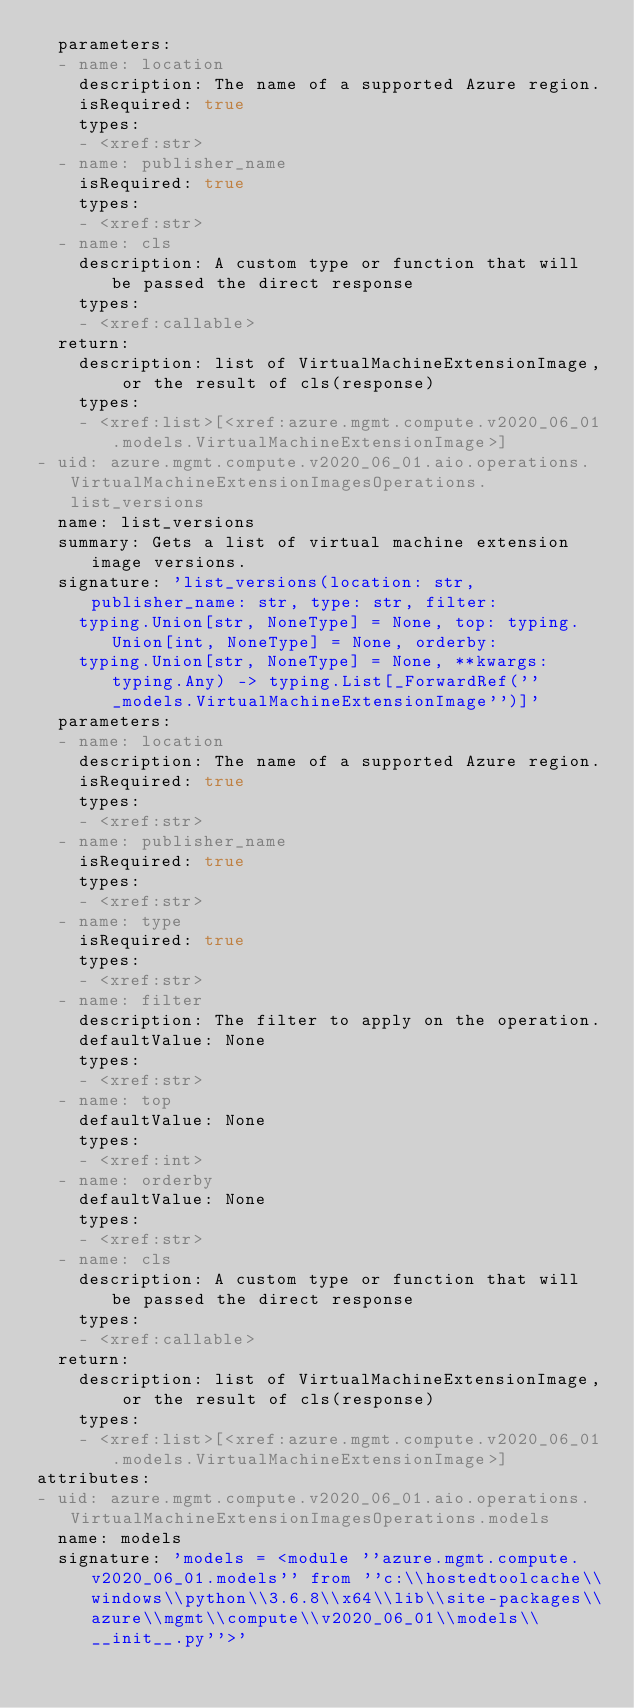Convert code to text. <code><loc_0><loc_0><loc_500><loc_500><_YAML_>  parameters:
  - name: location
    description: The name of a supported Azure region.
    isRequired: true
    types:
    - <xref:str>
  - name: publisher_name
    isRequired: true
    types:
    - <xref:str>
  - name: cls
    description: A custom type or function that will be passed the direct response
    types:
    - <xref:callable>
  return:
    description: list of VirtualMachineExtensionImage, or the result of cls(response)
    types:
    - <xref:list>[<xref:azure.mgmt.compute.v2020_06_01.models.VirtualMachineExtensionImage>]
- uid: azure.mgmt.compute.v2020_06_01.aio.operations.VirtualMachineExtensionImagesOperations.list_versions
  name: list_versions
  summary: Gets a list of virtual machine extension image versions.
  signature: 'list_versions(location: str, publisher_name: str, type: str, filter:
    typing.Union[str, NoneType] = None, top: typing.Union[int, NoneType] = None, orderby:
    typing.Union[str, NoneType] = None, **kwargs: typing.Any) -> typing.List[_ForwardRef(''_models.VirtualMachineExtensionImage'')]'
  parameters:
  - name: location
    description: The name of a supported Azure region.
    isRequired: true
    types:
    - <xref:str>
  - name: publisher_name
    isRequired: true
    types:
    - <xref:str>
  - name: type
    isRequired: true
    types:
    - <xref:str>
  - name: filter
    description: The filter to apply on the operation.
    defaultValue: None
    types:
    - <xref:str>
  - name: top
    defaultValue: None
    types:
    - <xref:int>
  - name: orderby
    defaultValue: None
    types:
    - <xref:str>
  - name: cls
    description: A custom type or function that will be passed the direct response
    types:
    - <xref:callable>
  return:
    description: list of VirtualMachineExtensionImage, or the result of cls(response)
    types:
    - <xref:list>[<xref:azure.mgmt.compute.v2020_06_01.models.VirtualMachineExtensionImage>]
attributes:
- uid: azure.mgmt.compute.v2020_06_01.aio.operations.VirtualMachineExtensionImagesOperations.models
  name: models
  signature: 'models = <module ''azure.mgmt.compute.v2020_06_01.models'' from ''c:\\hostedtoolcache\\windows\\python\\3.6.8\\x64\\lib\\site-packages\\azure\\mgmt\\compute\\v2020_06_01\\models\\__init__.py''>'
</code> 